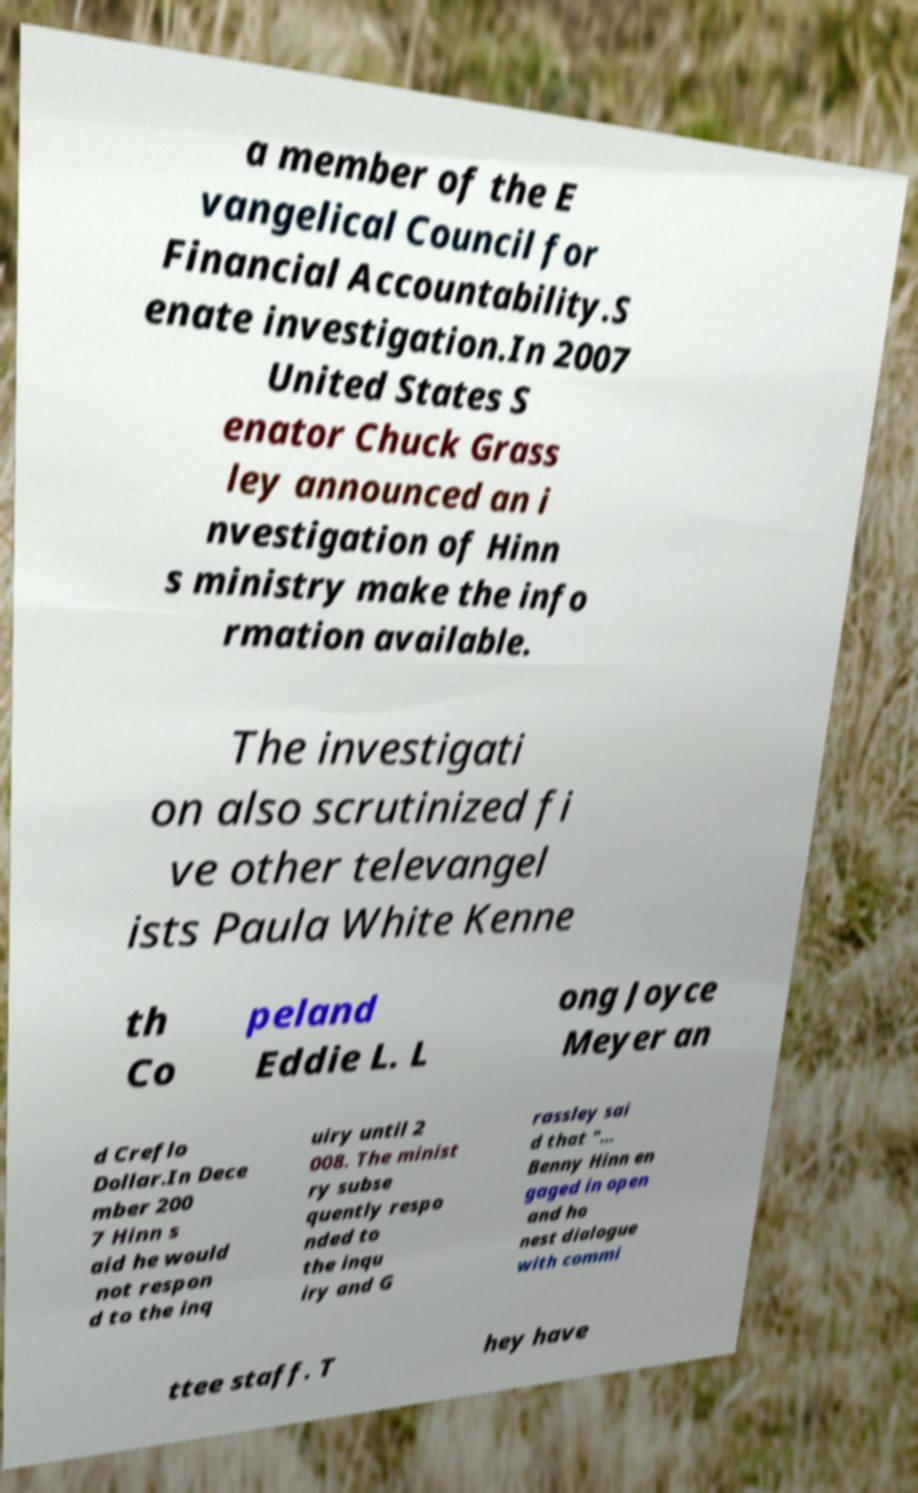Please identify and transcribe the text found in this image. a member of the E vangelical Council for Financial Accountability.S enate investigation.In 2007 United States S enator Chuck Grass ley announced an i nvestigation of Hinn s ministry make the info rmation available. The investigati on also scrutinized fi ve other televangel ists Paula White Kenne th Co peland Eddie L. L ong Joyce Meyer an d Creflo Dollar.In Dece mber 200 7 Hinn s aid he would not respon d to the inq uiry until 2 008. The minist ry subse quently respo nded to the inqu iry and G rassley sai d that "... Benny Hinn en gaged in open and ho nest dialogue with commi ttee staff. T hey have 